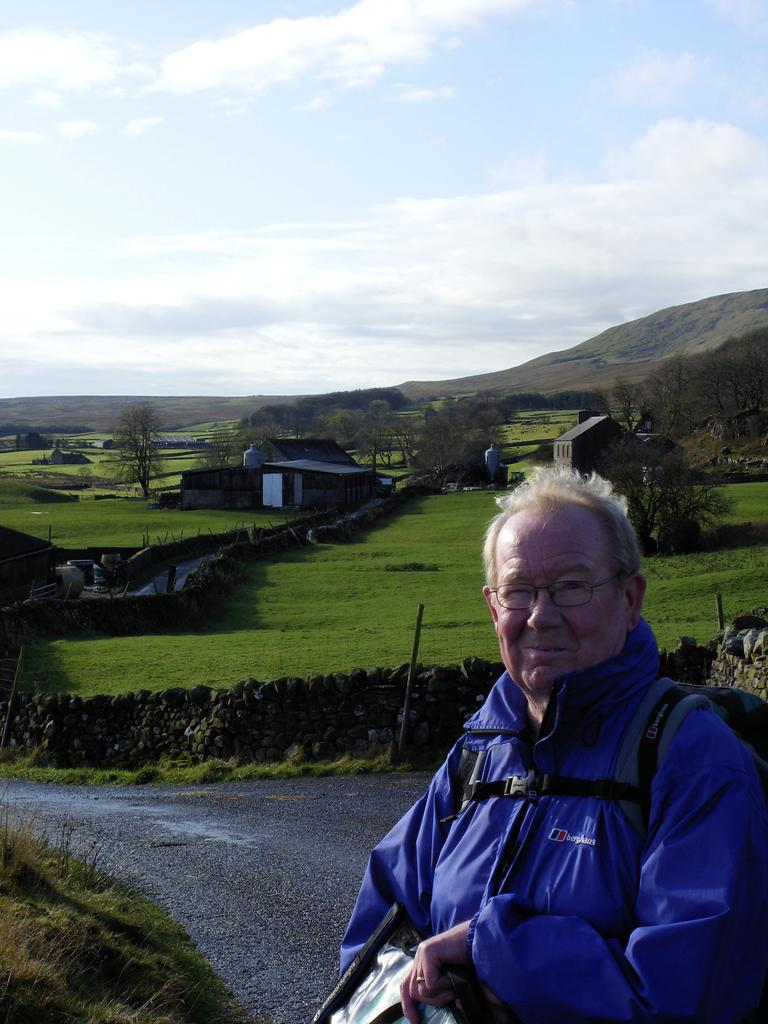Who is in the image? There is a person in the image. Where is the person located? The person is on the road. What is the person holding? The person is holding a bag. What can be seen in the background of the image? There are houses, trees, grass, and stones visible in the background of the image. What type of alarm is the scarecrow using to protect the crops in the image? There is no scarecrow or alarm present in the image. How does the person maintain their balance while walking on the stones in the image? The image does not show the person walking on stones, so it is not possible to determine how they maintain their balance. 